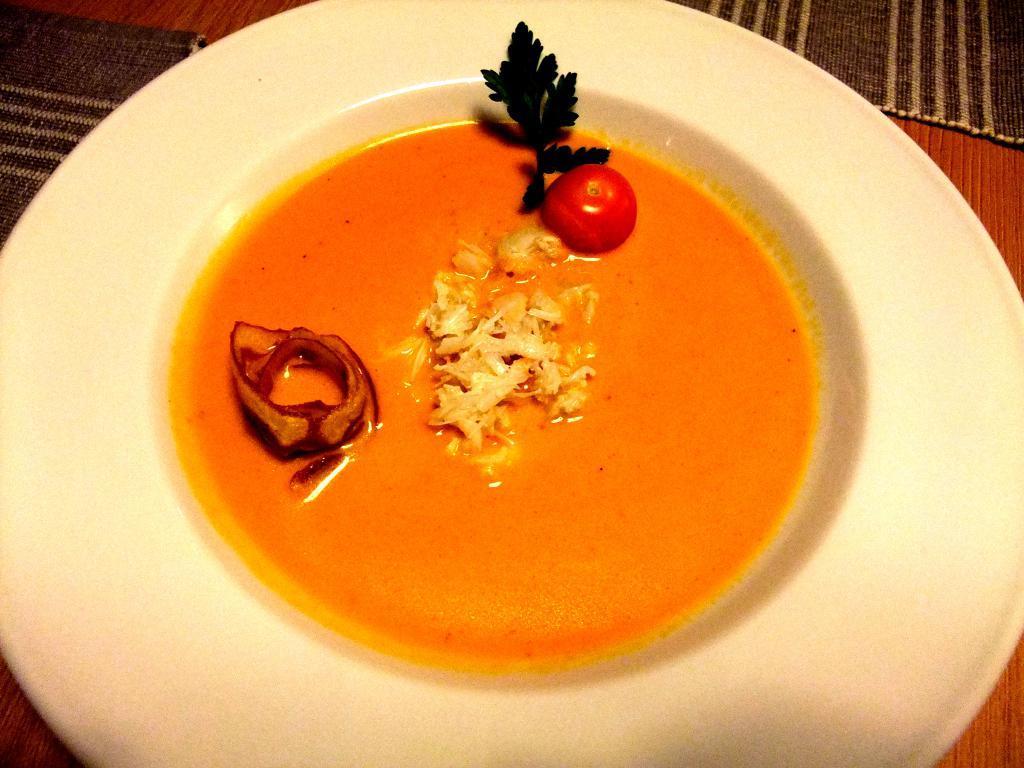Please provide a concise description of this image. In this image there is food on the plate which is in the center. 